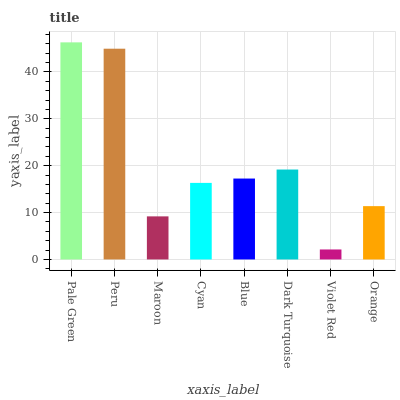Is Violet Red the minimum?
Answer yes or no. Yes. Is Pale Green the maximum?
Answer yes or no. Yes. Is Peru the minimum?
Answer yes or no. No. Is Peru the maximum?
Answer yes or no. No. Is Pale Green greater than Peru?
Answer yes or no. Yes. Is Peru less than Pale Green?
Answer yes or no. Yes. Is Peru greater than Pale Green?
Answer yes or no. No. Is Pale Green less than Peru?
Answer yes or no. No. Is Blue the high median?
Answer yes or no. Yes. Is Cyan the low median?
Answer yes or no. Yes. Is Peru the high median?
Answer yes or no. No. Is Peru the low median?
Answer yes or no. No. 